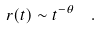Convert formula to latex. <formula><loc_0><loc_0><loc_500><loc_500>r ( t ) \sim t ^ { - \theta } \ \ .</formula> 